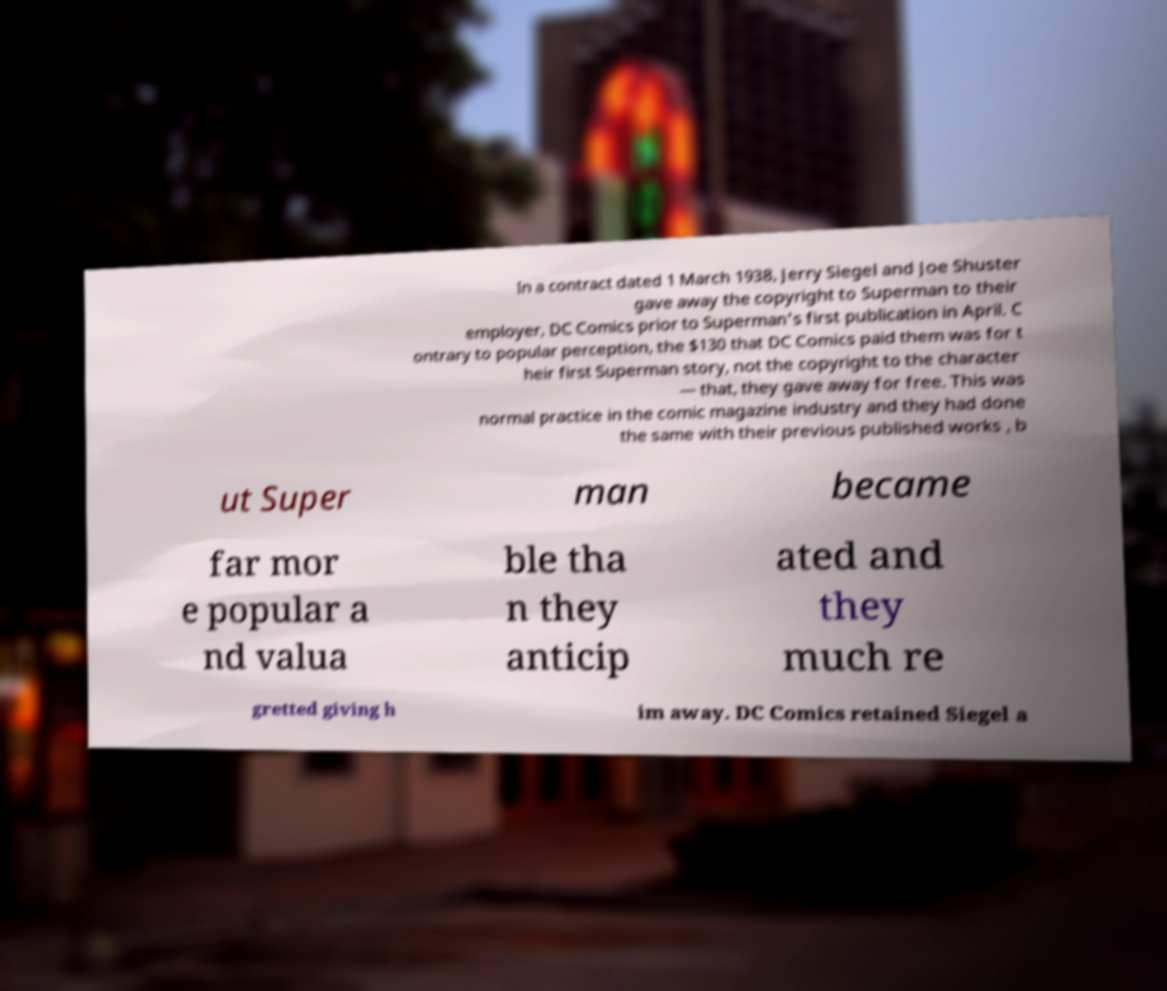Please read and relay the text visible in this image. What does it say? In a contract dated 1 March 1938, Jerry Siegel and Joe Shuster gave away the copyright to Superman to their employer, DC Comics prior to Superman's first publication in April. C ontrary to popular perception, the $130 that DC Comics paid them was for t heir first Superman story, not the copyright to the character — that, they gave away for free. This was normal practice in the comic magazine industry and they had done the same with their previous published works , b ut Super man became far mor e popular a nd valua ble tha n they anticip ated and they much re gretted giving h im away. DC Comics retained Siegel a 